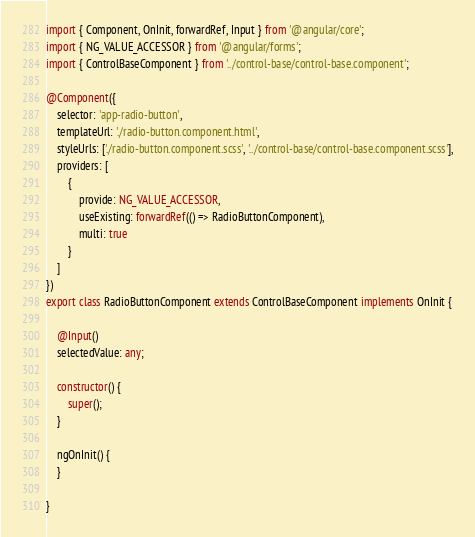<code> <loc_0><loc_0><loc_500><loc_500><_TypeScript_>import { Component, OnInit, forwardRef, Input } from '@angular/core';
import { NG_VALUE_ACCESSOR } from '@angular/forms';
import { ControlBaseComponent } from '../control-base/control-base.component';

@Component({
    selector: 'app-radio-button',
    templateUrl: './radio-button.component.html',
    styleUrls: ['./radio-button.component.scss', '../control-base/control-base.component.scss'],
    providers: [
        {
            provide: NG_VALUE_ACCESSOR,
            useExisting: forwardRef(() => RadioButtonComponent),
            multi: true
        }
    ]
})
export class RadioButtonComponent extends ControlBaseComponent implements OnInit {

    @Input()
    selectedValue: any;

    constructor() {
        super();
    }

    ngOnInit() {
    }

}
</code> 